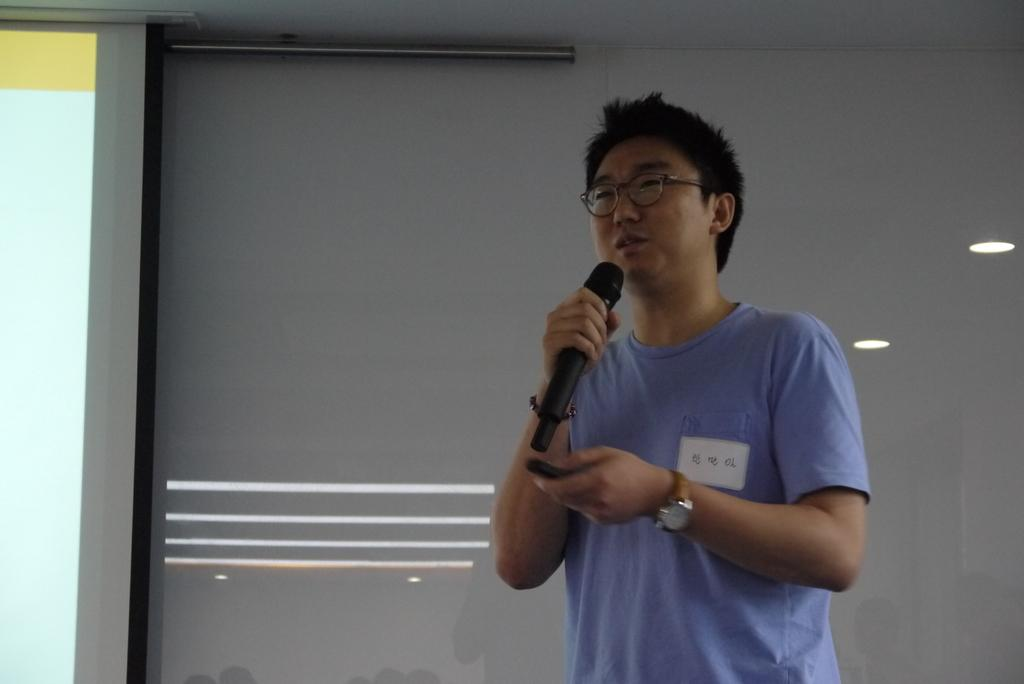What is the person in the image doing? The person is standing and holding a microphone. What can be seen in the background of the image? There is a projection screen in the background of the image. What is visible on the projection screen? There are reflections of lights on the projection screen. What type of scissors can be seen cutting through the letters on the projection screen? There are no scissors or letters present on the projection screen in the image. 